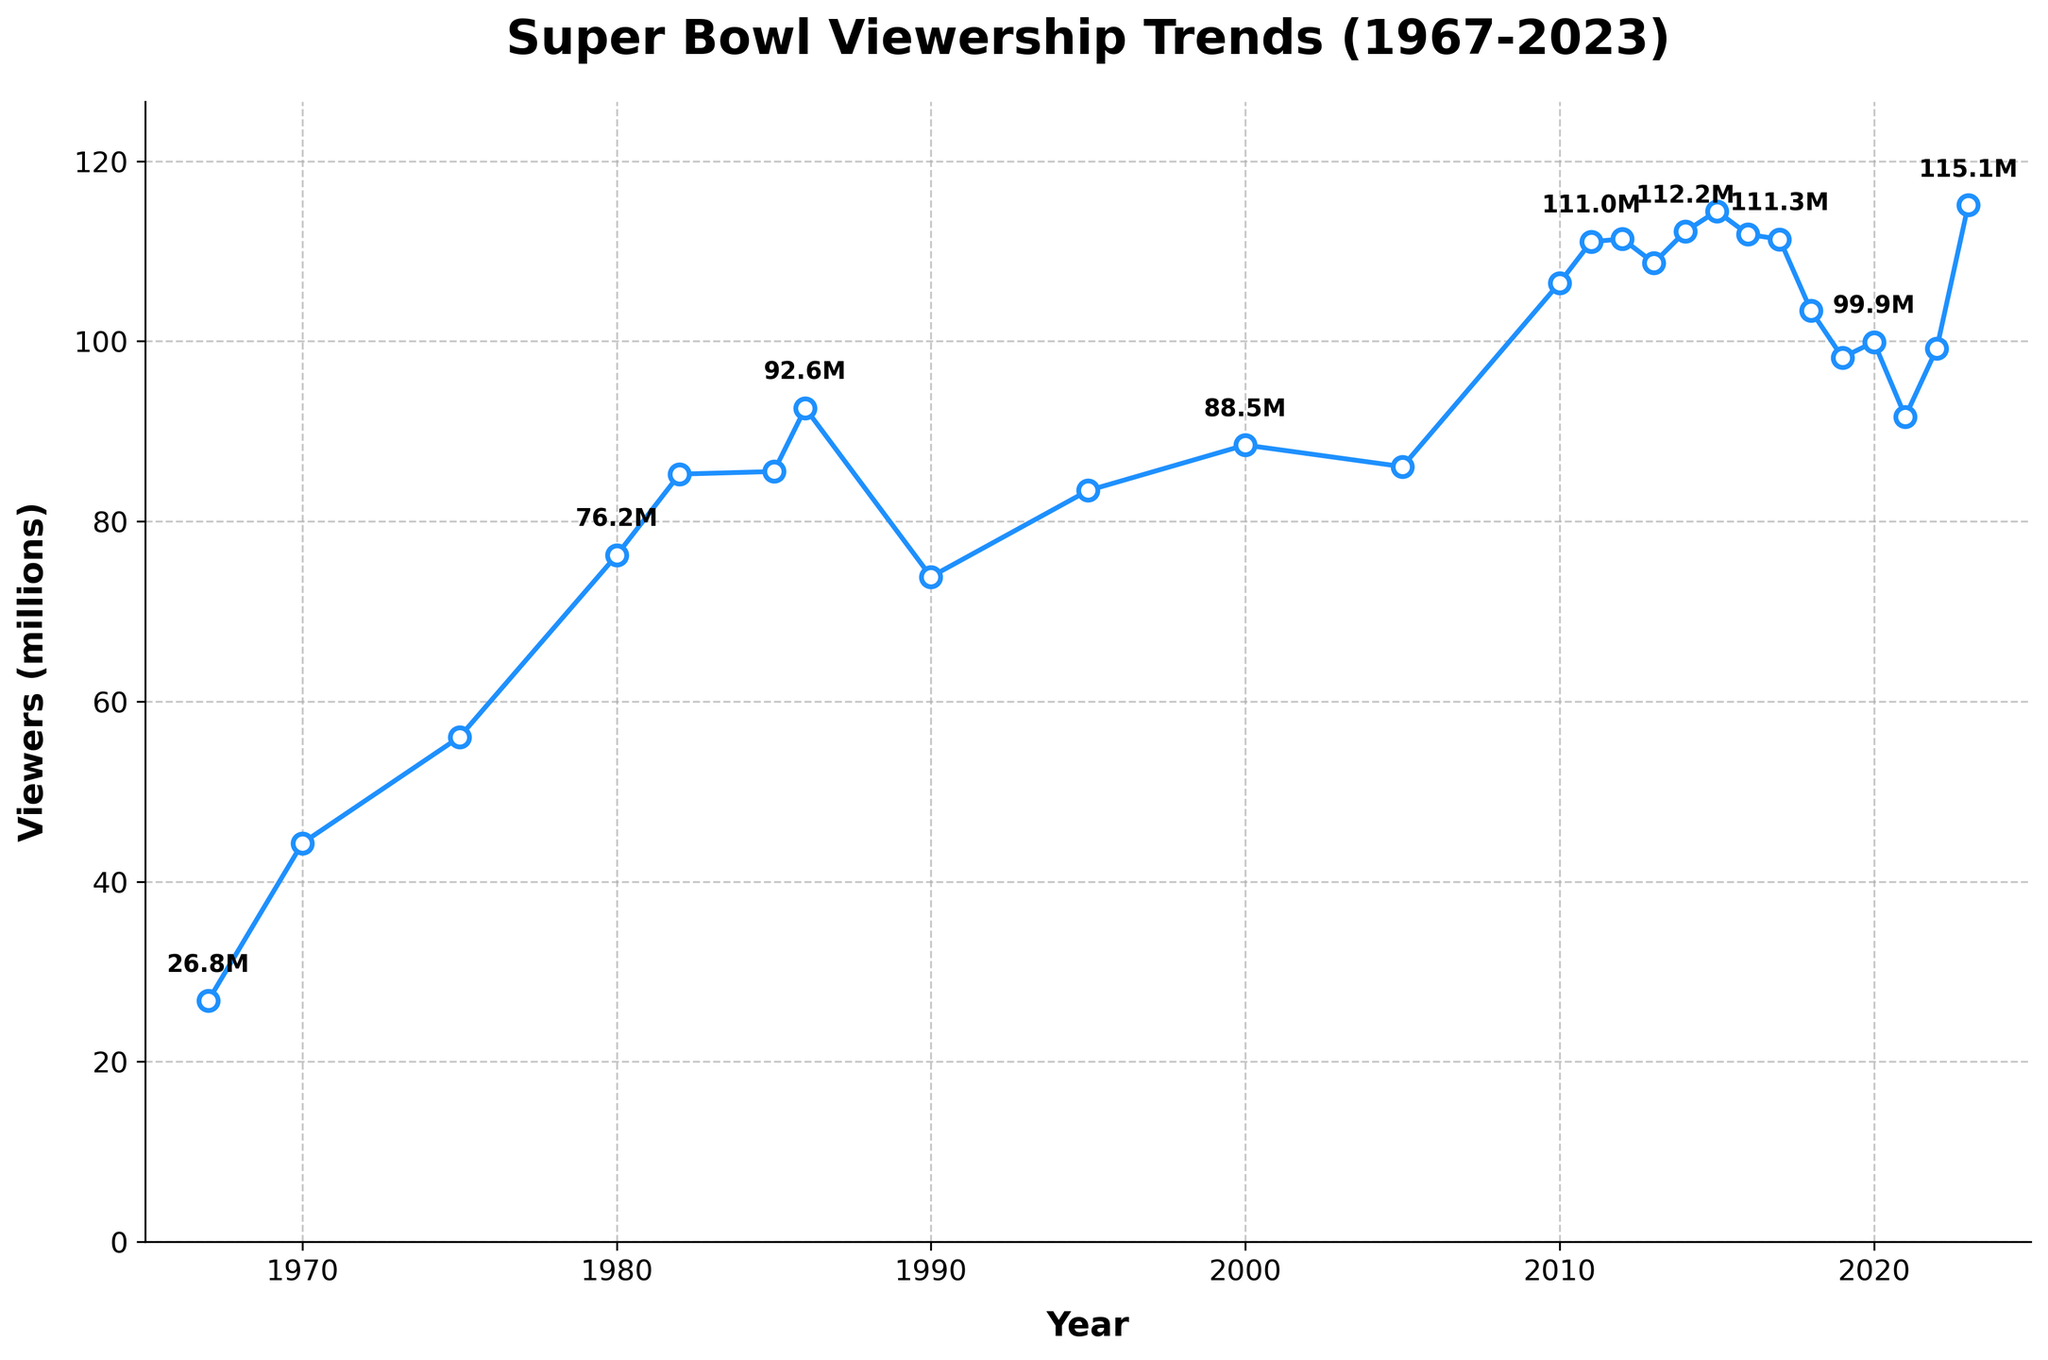What was the year with the highest Super Bowl viewership? The highest data point on the y-axis reflects the peak viewership. From the plot, locate the highest point, which is labeled as 115.1 million viewers. The corresponding year on the x-axis is 2023.
Answer: 2023 How did the Super Bowl viewership change between 1986 and 1990? Look at the points corresponding to 1986 and 1990 on the plot. In 1986, the viewership was 92.57 million, and in 1990, it was 73.85 million. The difference is 92.57 - 73.85 = 18.72 million.
Answer: Decreased by 18.72 million What is the viewership difference between 2015 and 2023? Check the points for 2015 and 2023. In 2015, the viewership was 114.44 million, and in 2023, it was 115.1 million. The difference is 115.1 - 114.44 = 0.66 million.
Answer: 0.66 million Which period had a steeper increase in viewership, 1970-1975 or 2005-2010? Compare the slope (rate of increase) between the two periods. For 1970-1975, the increase is 56.05 - 44.27 = 11.78 million over 5 years. For 2005-2010, the increase is 106.48 - 86.07 = 20.41 million over 5 years. The increase in 2005-2010 is greater.
Answer: 2005-2010 How many times did the viewership exceed 100 million? Identify and count points on the y-axis that surpass 100 million. These years are 2010-2017, 2019, 2020, 2022, and 2023. This makes for 11 occurrences.
Answer: 11 times In which decade did viewership increase the most? Calculate the increase from the starting to ending year of each decade. For instance, from 1980 to 1990, it increases from 76.24 million to 73.85 million, which is a decrease. By examining, 2010-2020 shows an increase from 106.48 to 99.91 million. Thus 1970s and 2010s need attention.
Answer: 2010s What is the average viewership of the Super Bowls in the 2010s? Sum the viewership from 2010 to 2019: 106.48 + 111.04 + 111.35 + 108.69 + 112.19 + 114.44 + 111.86 + 111.32 + 103.39 + 98.19 = 1088.95 million. Divide by the number of years, 1088.95/10 = 108.895 million.
Answer: 108.895 million 